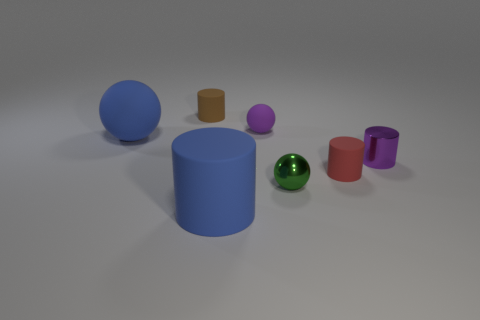Subtract all brown cylinders. How many cylinders are left? 3 Subtract all small red cylinders. How many cylinders are left? 3 Add 3 metal cylinders. How many objects exist? 10 Subtract 1 spheres. How many spheres are left? 2 Subtract all cylinders. How many objects are left? 3 Subtract all gray cylinders. Subtract all gray balls. How many cylinders are left? 4 Add 1 tiny red cylinders. How many tiny red cylinders exist? 2 Subtract 0 yellow blocks. How many objects are left? 7 Subtract all tiny green shiny objects. Subtract all metallic balls. How many objects are left? 5 Add 7 metallic balls. How many metallic balls are left? 8 